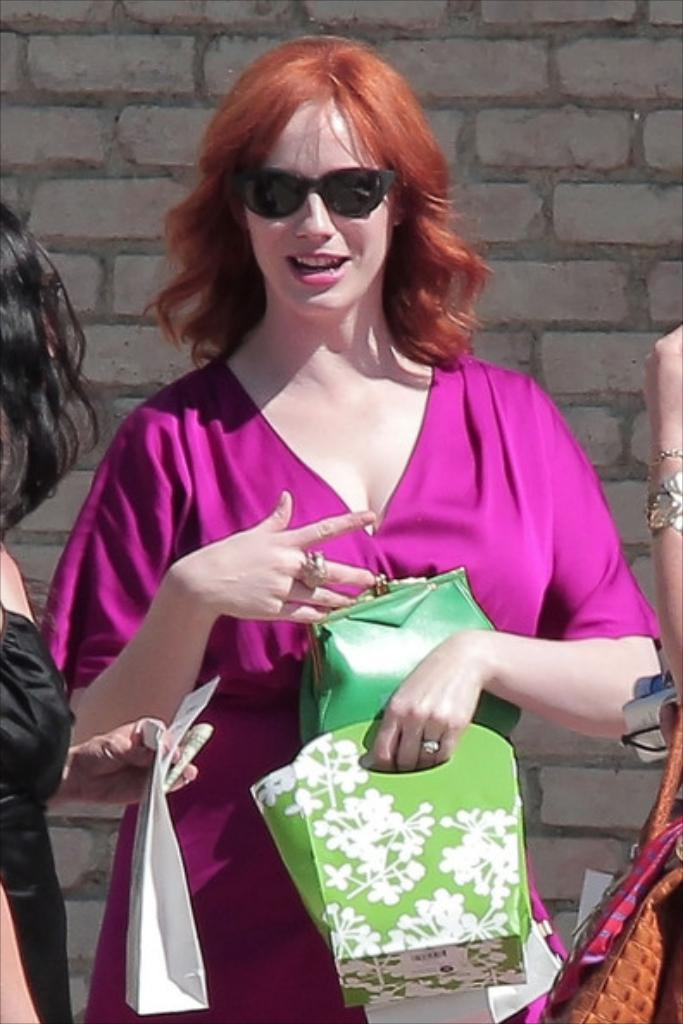Who is the main subject in the image? There is a woman in the image. What is the woman wearing? The woman is wearing a pink dress. What accessory is the woman wearing? The woman is wearing spectacles. What is the woman holding in the image? The woman is holding bags. What can be seen in the background of the image? There is a wall in the background of the image. What type of brush can be seen in the woman's hand in the image? There is no brush present in the woman's hand in the image. How many trees are visible in the background of the image? There are no trees visible in the background of the image; only a wall is present. 